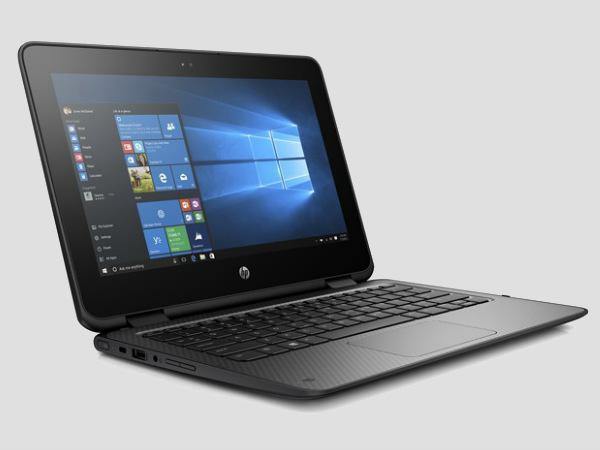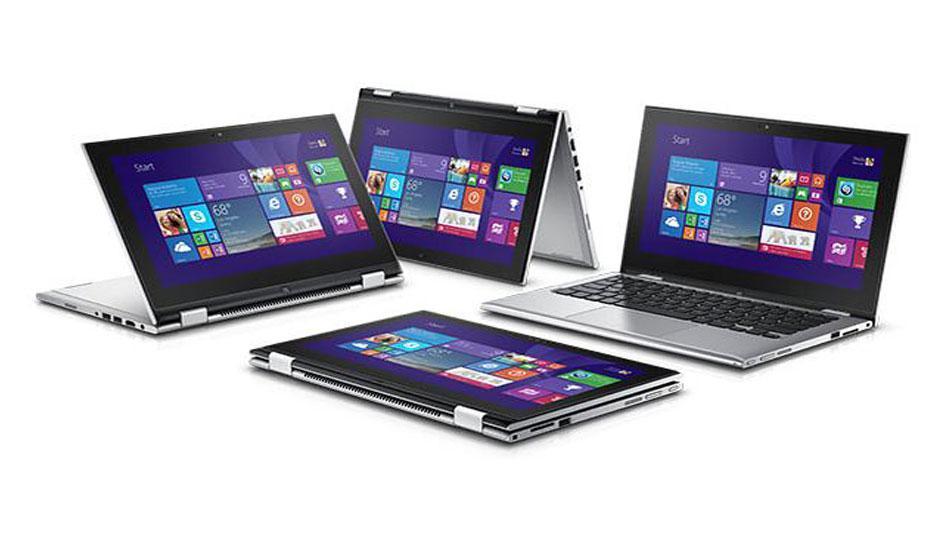The first image is the image on the left, the second image is the image on the right. Analyze the images presented: Is the assertion "One laptop is shown with the monitor and keyboard disconnected from each other." valid? Answer yes or no. No. The first image is the image on the left, the second image is the image on the right. Assess this claim about the two images: "The left image contains at least two laptop computers.". Correct or not? Answer yes or no. No. 